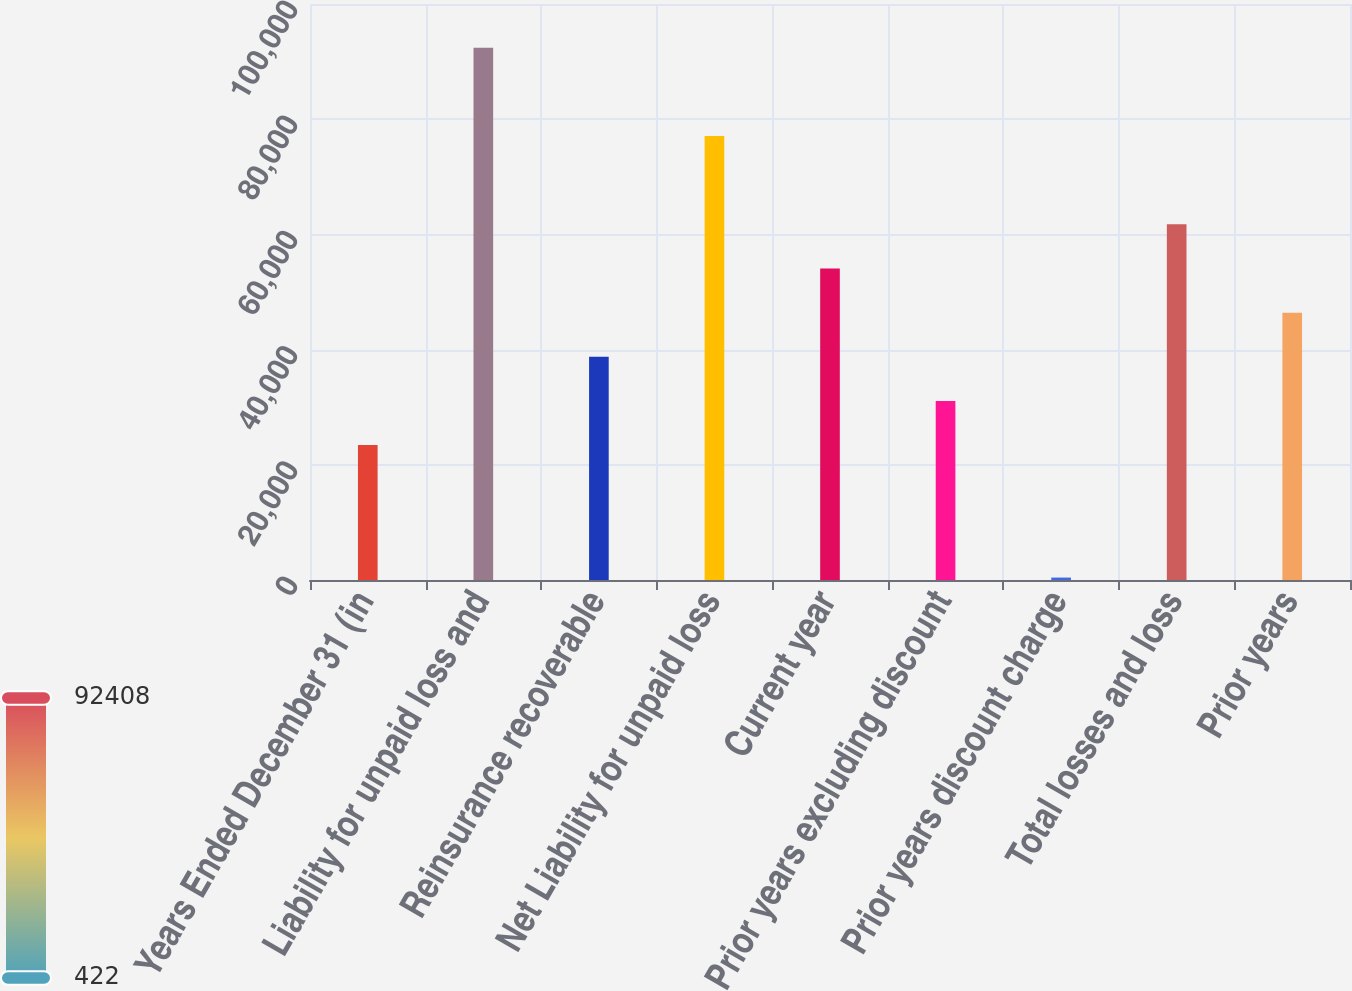Convert chart. <chart><loc_0><loc_0><loc_500><loc_500><bar_chart><fcel>Years Ended December 31 (in<fcel>Liability for unpaid loss and<fcel>Reinsurance recoverable<fcel>Net Liability for unpaid loss<fcel>Current year<fcel>Prior years excluding discount<fcel>Prior years discount charge<fcel>Total losses and loss<fcel>Prior years<nl><fcel>23418.5<fcel>92408<fcel>38749.5<fcel>77077<fcel>54080.5<fcel>31084<fcel>422<fcel>61746<fcel>46415<nl></chart> 